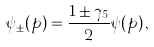<formula> <loc_0><loc_0><loc_500><loc_500>\psi _ { \pm } ( p ) = { \frac { 1 \pm \gamma _ { 5 } } { 2 } } \psi ( p ) \, ,</formula> 